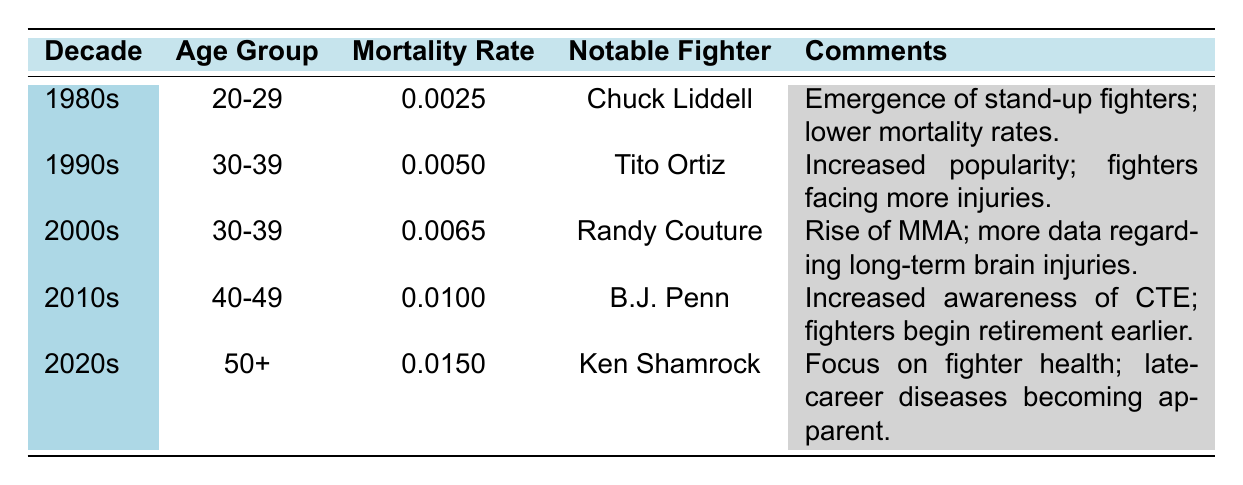What is the mortality rate for fighters in their 20s during the 1980s? According to the table, for the decade of the 1980s, the age group 20-29 has a mortality rate of 0.0025.
Answer: 0.0025 Which notable fighter is associated with the decade of the 1990s? The table indicates that Tito Ortiz is the notable fighter for the 1990s.
Answer: Tito Ortiz What was the age group with the highest mortality rate in the 2010s? Reviewing the table, the age group 40-49 has a mortality rate of 0.0100 in the 2010s, which is higher than that of the other age groups listed.
Answer: 40-49 Is the mortality rate for fighters in the 2020s higher than in the 1980s? The 2020s have a mortality rate of 0.0150, while the 1980s have a mortality rate of 0.0025. Since 0.0150 is greater than 0.0025, the answer is yes.
Answer: Yes What is the average mortality rate for the age group 30-39 across the 1990s and 2000s? The mortality rates for the age group 30-39 are 0.0050 for the 1990s and 0.0065 for the 2000s. Summing these rates gives 0.0050 + 0.0065 = 0.0115. There are 2 data points, so the average is 0.0115 / 2 = 0.00575.
Answer: 0.00575 Which decade's notable fighter had an associated comment about increased awareness of CTE? According to the table, B.J. Penn is the notable fighter for the 2010s, and the comment related to him mentions the increased awareness of Chronic Traumatic Encephalopathy (CTE).
Answer: 2010s What is the difference in mortality rates between the 2020s and the 2000s? The mortality rate for the 2020s is 0.0150 and for the 2000s, it is 0.0065. To find the difference, subtract 0.0065 from 0.0150: 0.0150 - 0.0065 = 0.0085.
Answer: 0.0085 In which decade is Ken Shamrock noted, and what is his age category? The table shows that Ken Shamrock is noted in the 2020s, specifically in the age group of 50+.
Answer: 2020s, 50+ Is it true that all the notable fighters mentioned were part of the UFC? There is no specific information in the table indicating that all notable fighters like Chuck Liddell, Tito Ortiz, Randy Couture, B.J. Penn, and Ken Shamrock were part of the UFC; therefore, this statement cannot be confirmed as true.
Answer: No 